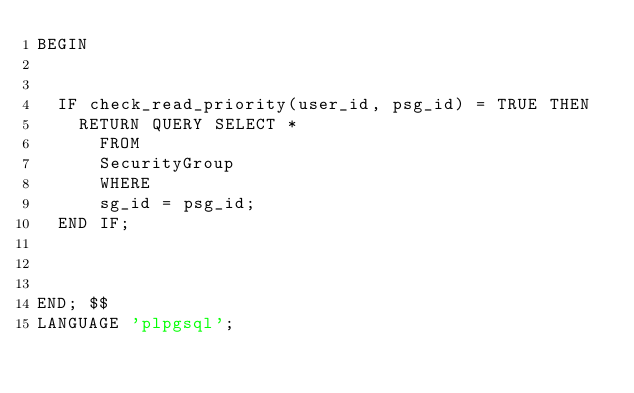Convert code to text. <code><loc_0><loc_0><loc_500><loc_500><_SQL_>BEGIN
	
	
	IF check_read_priority(user_id, psg_id) = TRUE THEN 
		RETURN QUERY SELECT *
			FROM
			SecurityGroup
			WHERE
			sg_id = psg_id;
	END IF;

	
	
END; $$
LANGUAGE 'plpgsql';
</code> 